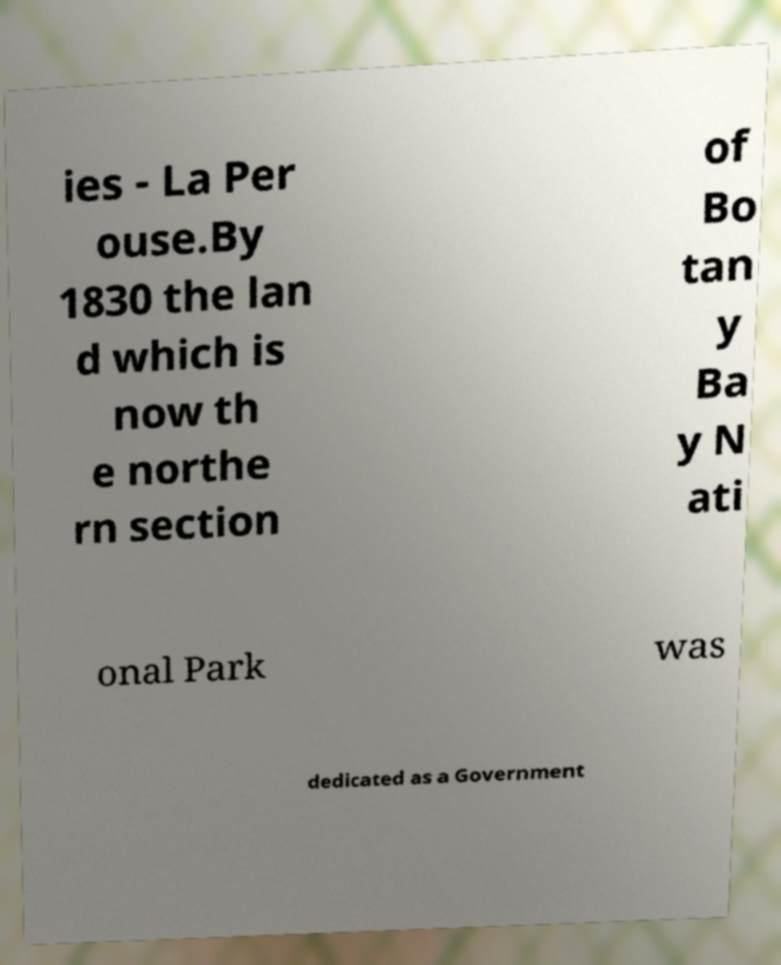Please identify and transcribe the text found in this image. ies - La Per ouse.By 1830 the lan d which is now th e northe rn section of Bo tan y Ba y N ati onal Park was dedicated as a Government 